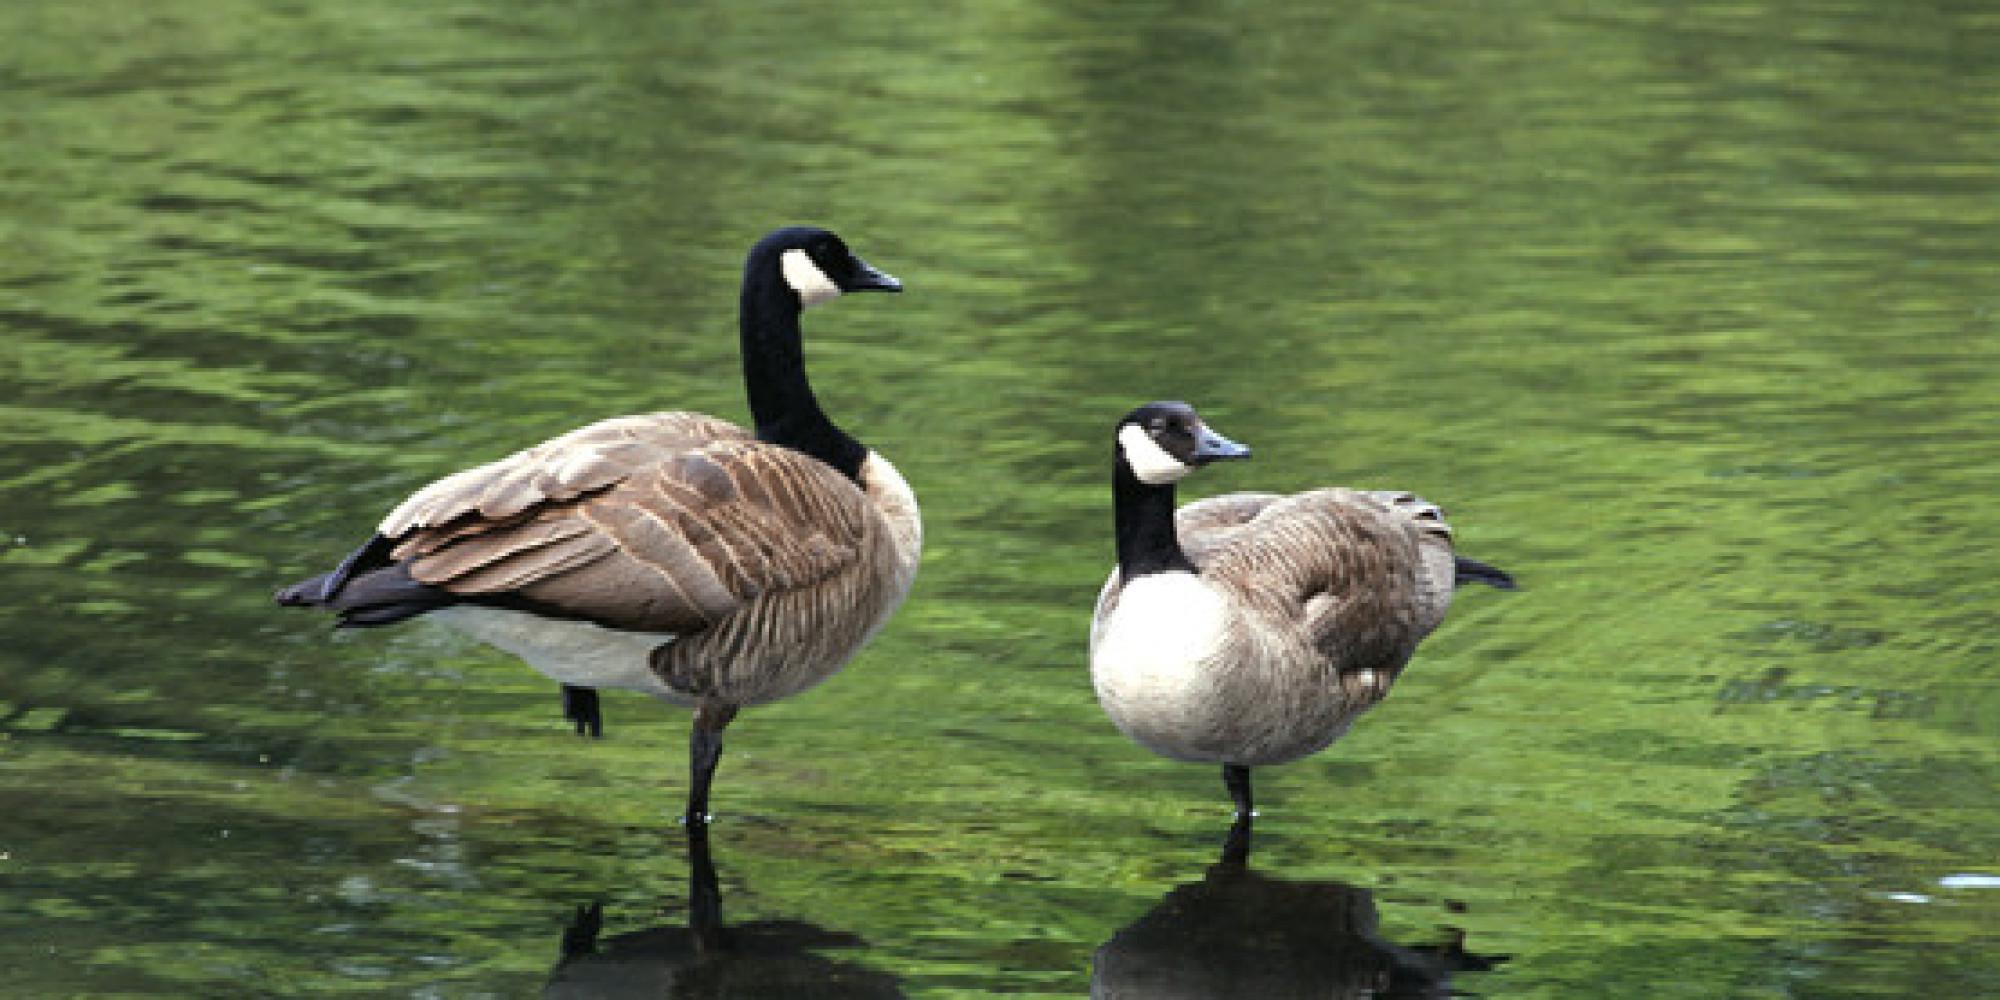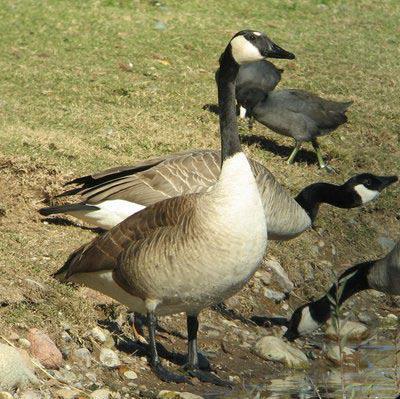The first image is the image on the left, the second image is the image on the right. Given the left and right images, does the statement "One of the images shows exactly two geese." hold true? Answer yes or no. Yes. The first image is the image on the left, the second image is the image on the right. For the images shown, is this caption "Exactly two Canada geese are in or near a body of water." true? Answer yes or no. Yes. 